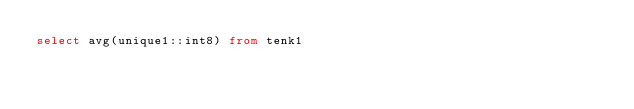<code> <loc_0><loc_0><loc_500><loc_500><_SQL_>select avg(unique1::int8) from tenk1
</code> 